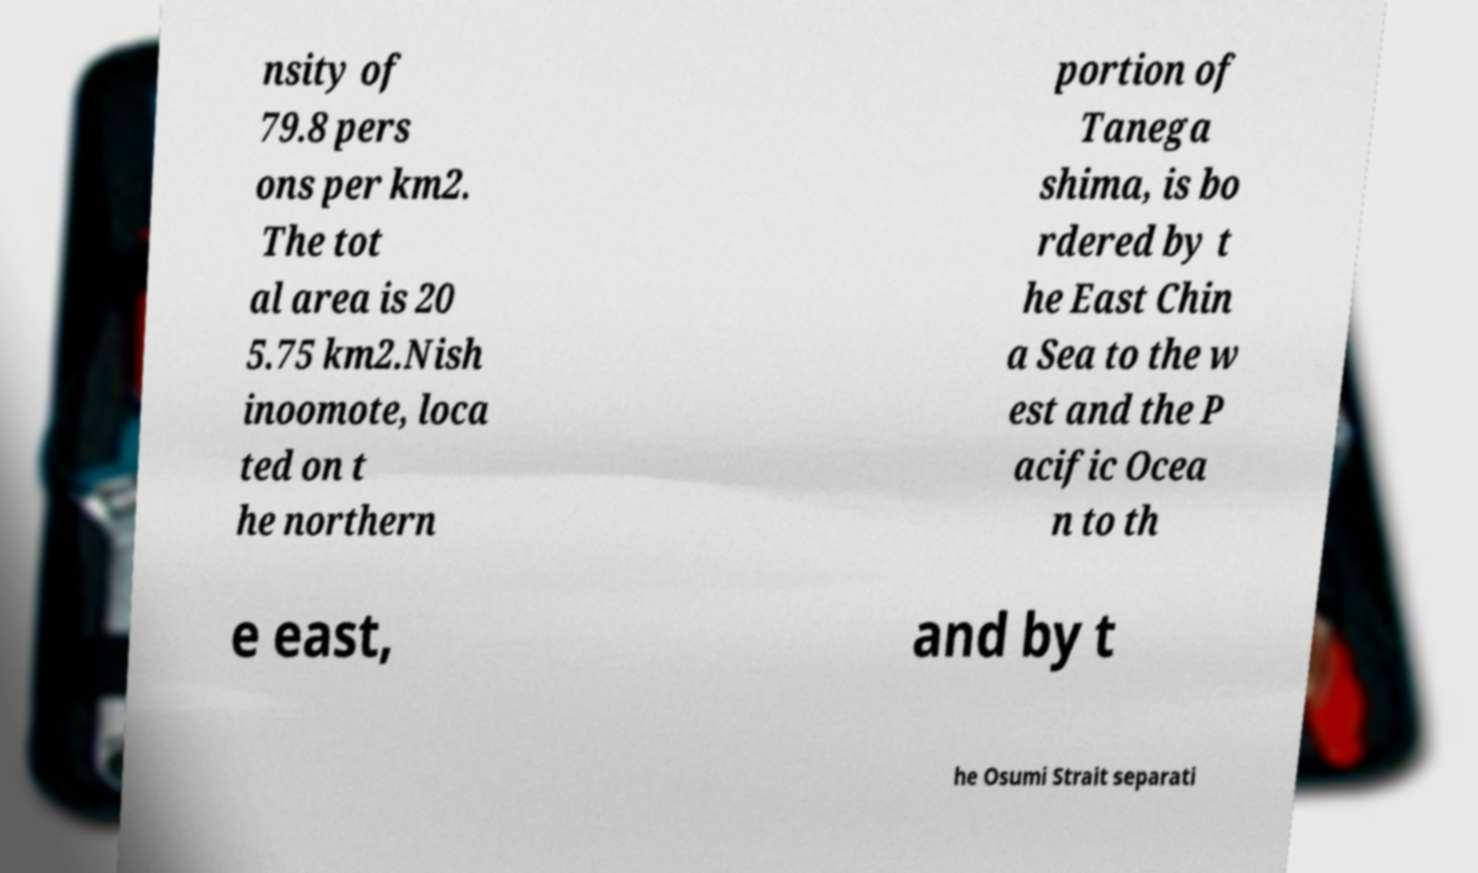What messages or text are displayed in this image? I need them in a readable, typed format. nsity of 79.8 pers ons per km2. The tot al area is 20 5.75 km2.Nish inoomote, loca ted on t he northern portion of Tanega shima, is bo rdered by t he East Chin a Sea to the w est and the P acific Ocea n to th e east, and by t he Osumi Strait separati 